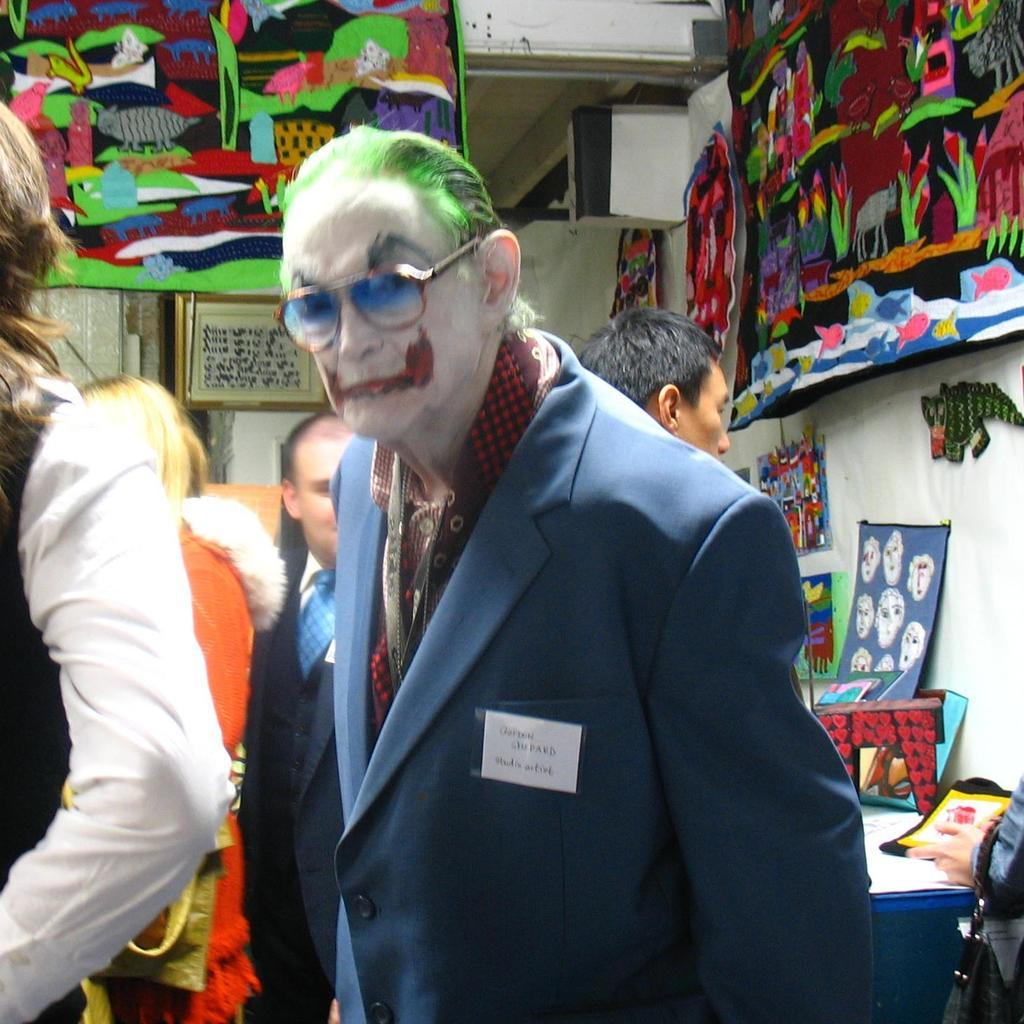How many people are visible in the image? There are two people standing in the image. Can you describe one of the men in the image? One of the men is wearing glasses. What can be seen in the background of the image? There are people, a wall, and posters in the background of the image. What is on the table in the image? There are objects on a table in the image. What degree of rain is expected in the image? There is no mention of rain in the image, so it is not possible to determine the degree of rain. Can you see any pipes in the image? There are no pipes visible in the image. 